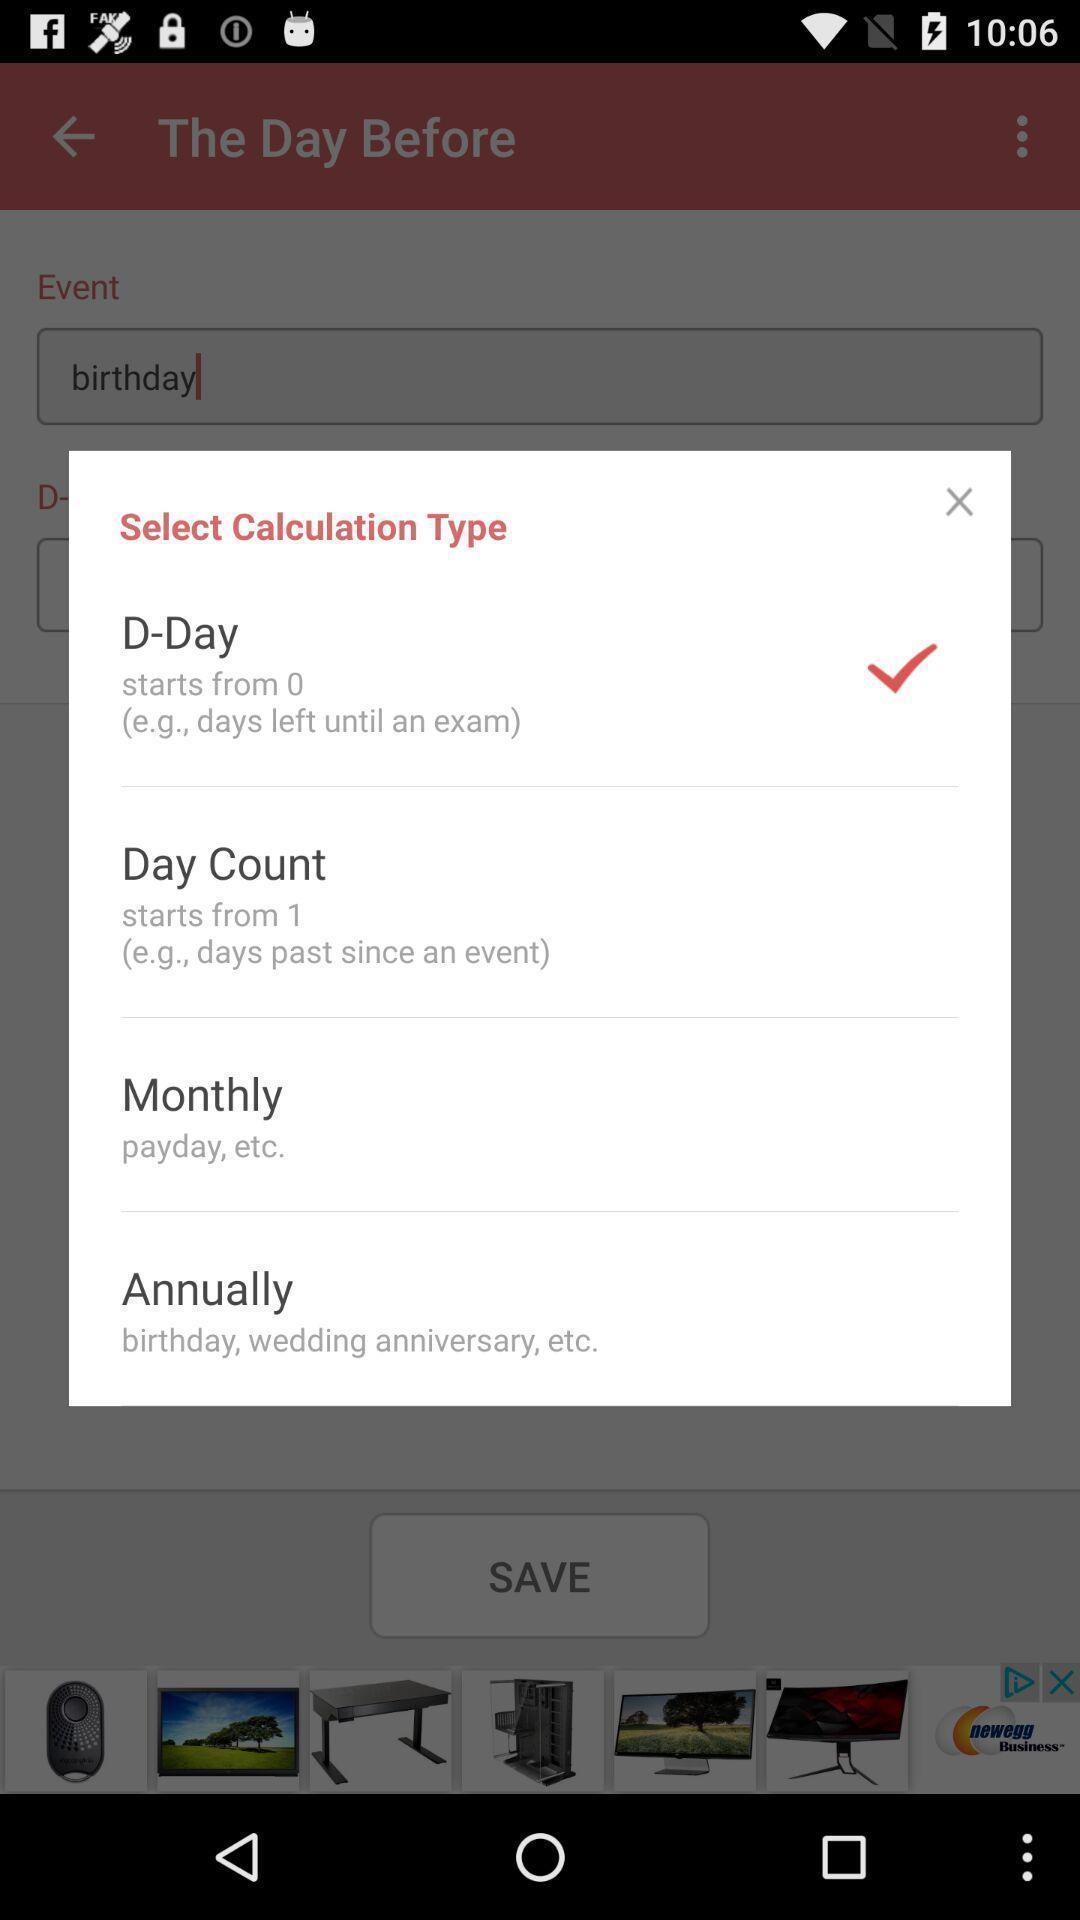Describe this image in words. Pop-up about the calculation of the day. 